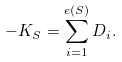<formula> <loc_0><loc_0><loc_500><loc_500>- K _ { S } = \sum _ { i = 1 } ^ { e ( S ) } D _ { i } .</formula> 